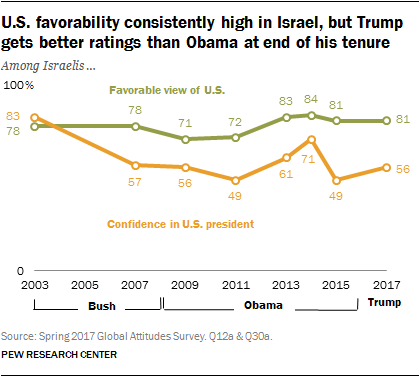Mention a couple of crucial points in this snapshot. The color of a graph whose rightmost value is 81 is green. The median value of the orange graph is 56.5. 